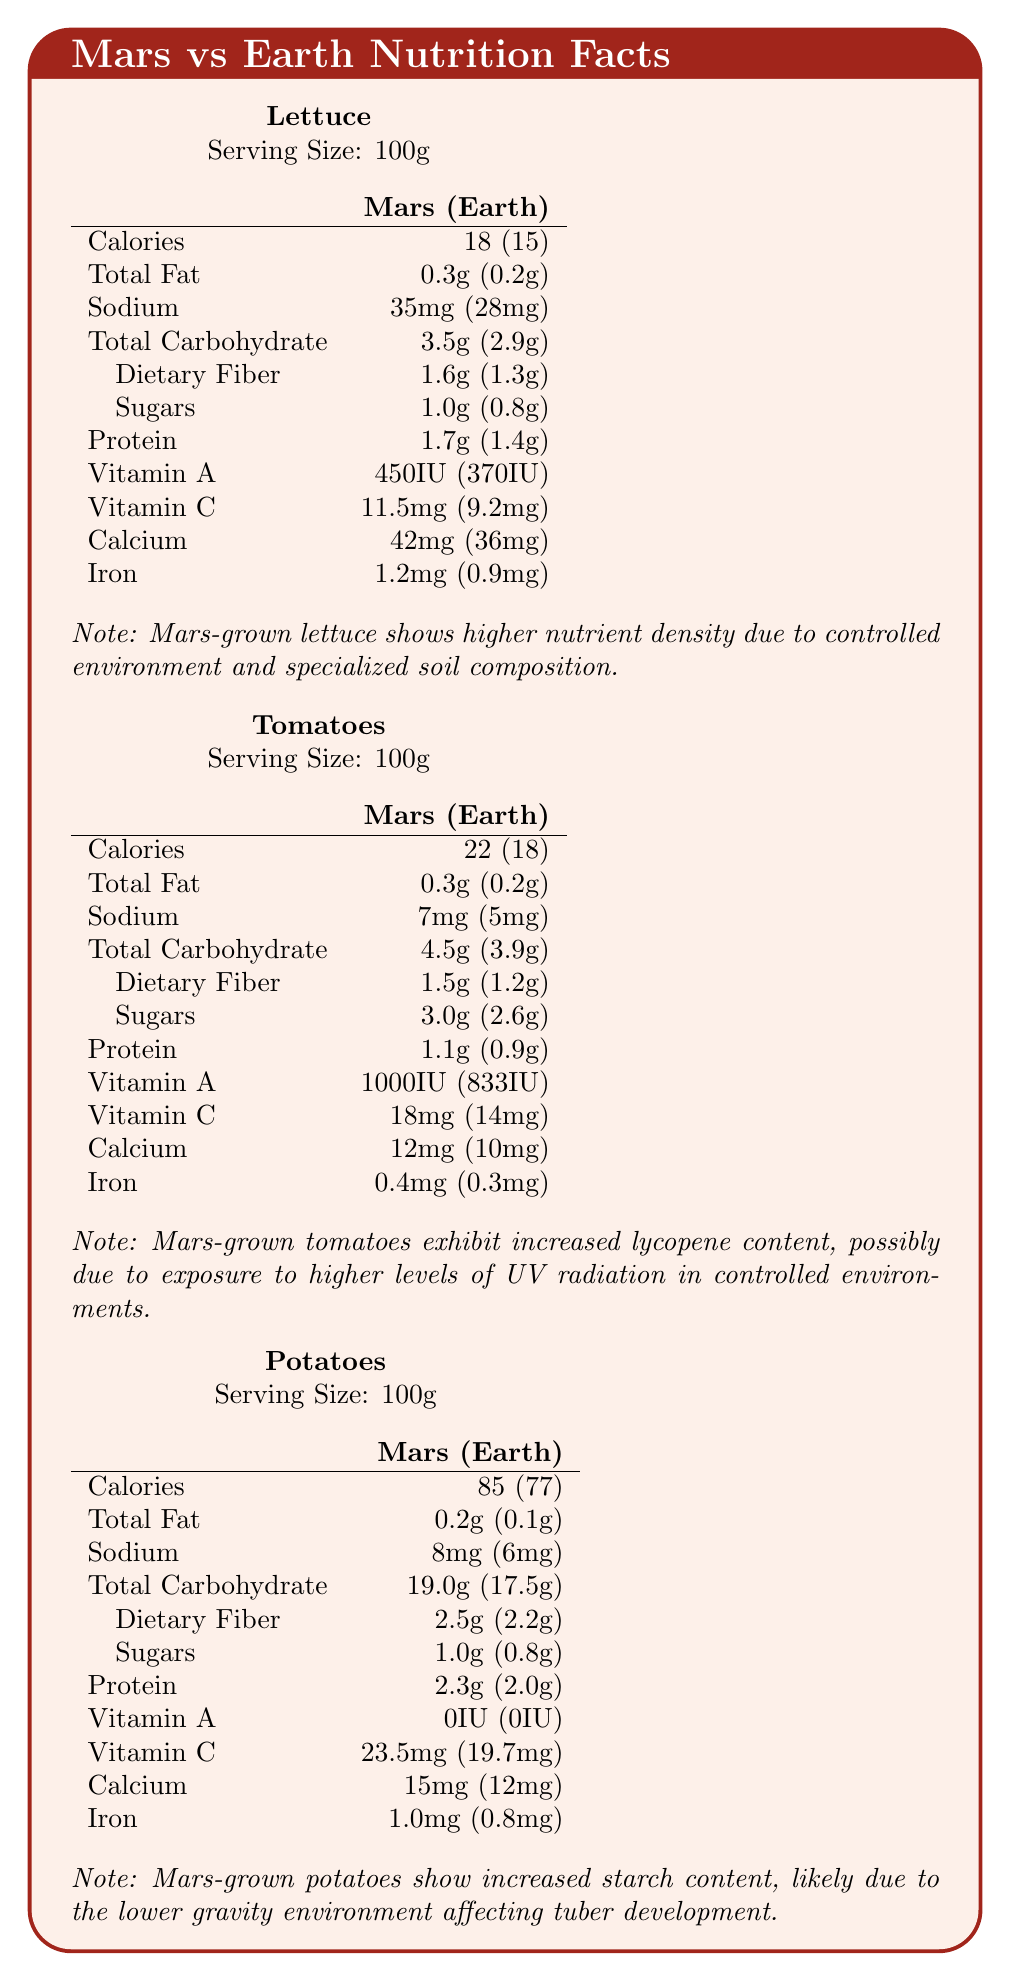what is the calorie difference between Mars-grown and Earth-grown lettuce? Mars-grown lettuce has 18 calories per 100g, while Earth-grown lettuce has 15 calories per 100g.
Answer: 3 calories what is the protein content of Mars-grown potatoes? The protein content of Mars-grown potatoes is listed as 2.3g per 100g.
Answer: 2.3g how much more vitamin C do Mars-grown tomatoes have compared to their Earth-grown counterparts? Mars-grown tomatoes have 18mg of vitamin C, compared to 14mg in Earth-grown tomatoes.
Answer: 4mg what is the calcium content in Mars-grown lettuce? The calcium content in Mars-grown lettuce is listed as 42mg per 100g.
Answer: 42mg what is the serving size for all vegetables listed? The serving size for lettuce, tomatoes, and potatoes is indicated as 100g.
Answer: 100g how does the sodium content of Mars-grown tomatoes compare to Earth-grown tomatoes? A. 2mg more B. 7mg more C. 5mg more Mars-grown tomatoes have 7mg of sodium compared to 5mg in Earth-grown tomatoes.
Answer: A. 2mg more which vitamin shows a significant increase in Mars-grown tomatoes? A. Vitamin A B. Vitamin C C. Vitamin B The vitamin A content in Mars-grown tomatoes is 1000IU, compared to 833IU in Earth-grown tomatoes.
Answer: A. Vitamin A does Mars-grown lettuce have higher iron content than Earth-grown lettuce? Mars-grown lettuce has 1.2mg of iron, while Earth-grown lettuce has 0.9mg of iron.
Answer: Yes does the document indicate the average temperature on Mars? The document states the average temperature on Mars as -63°C.
Answer: Yes summarize the main idea of the document. The document provides a comparative analysis of the nutritional content between Mars-grown and Earth-grown vegetables, including contextual notes on the growing conditions and their potential impacts on nutrient levels. It discusses how factors like specialized soil, UV radiation exposure, and gravity differences contribute to the nutritional profiles observed.
Answer: The document compares the nutritional content of Mars-grown and Earth-grown vegetables, specifically lettuce, tomatoes, and potatoes. It highlights differences in calories, vitamins, minerals, and other nutrients due to Mars' growing conditions, like controlled environments and specialized soil composition. It also includes notes on how these conditions may affect nutrient density, starch content, and other factors. what is the sodium content of Mars-grown potatoes? The sodium content of Mars-grown potatoes is listed as 8mg per 100g.
Answer: 8mg which vegetable shows the highest increase in calories when grown on Mars compared to Earth? A. Lettuce B. Tomatoes C. Potatoes Mars-grown potatoes have 85 calories compared to 77 calories in Earth-grown potatoes, showing the highest absolute increase in calories among the vegetables listed.
Answer: C. Potatoes what are some research methods mentioned for studying Mars-grown vegetables? The document lists hydroponic systems, regolith simulant studies in Mars analog facilities, long-term effects of radiation on plant genetics, comparative spectral analysis, and Martian atmospheric composition experiments as research methods.
Answer: Hydroponic systems, regolith simulant studies, long-term radiation effects, spectral analysis, atmospheric composition experiments how does the carbohydrate content of Mars-grown lettuce compare to Earth-grown lettuce? Mars-grown lettuce has 3.5g of carbohydrates per 100g, while Earth-grown lettuce has 2.9g, making it 0.6g more.
Answer: 0.6g more what specific advantage does Mars-grown lettuce have according to the notes? The notes indicate that Mars-grown lettuce shows higher nutrient density due to controlled environment and specialized soil composition.
Answer: Higher nutrient density what is the general sodium content trend for Mars-grown vegetables compared to Earth-grown ones? Mars-grown vegetables generally have higher sodium content compared to their Earth-grown counterparts, as shown in the comparisons of lettuce, tomatoes, and potatoes.
Answer: Higher how is the iron content different in Mars-grown potatoes compared to Earth-grown potatoes? Mars-grown potatoes have 1.0mg of iron per 100g, compared to 0.8mg in Earth-grown potatoes, a difference of 0.2mg.
Answer: 0.2mg more what is the main reason for increased lycopene content in Mars-grown tomatoes according to the notes? The notes suggest that the increased lycopene content in Mars-grown tomatoes could be due to exposure to higher levels of UV radiation in controlled environments.
Answer: Exposure to higher levels of UV radiation which vegetable has immediate differences in vitamin A content when comparing Mars-grown to Earth-grown varieties? A. Lettuce B. Potatoes C. Tomatoes Mars-grown tomatoes have a notably higher vitamin A content (1000IU) compared to Earth-grown tomatoes (833IU).
Answer: C. Tomatoes which vegetable shows no difference in vitamin A content between Mars-grown and Earth-grown varieties? Both Mars-grown and Earth-grown potatoes have 0IU of vitamin A.
Answer: Potatoes 